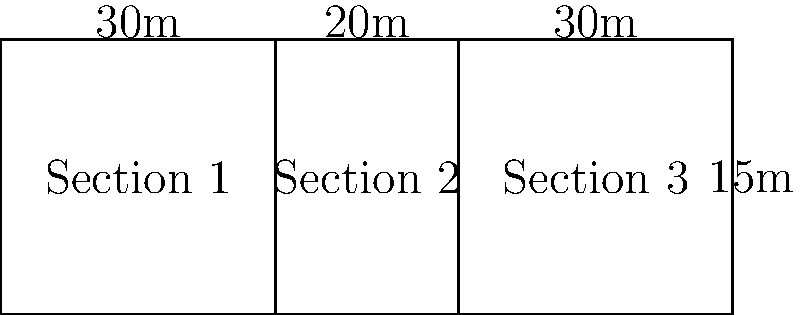As a forestry manager overseeing road maintenance, you need to resurface a section of forest road. The road is divided into three rectangular sections as shown in the diagram. The total length of the road is 80 meters, and its width is 15 meters. The first and third sections are each 30 meters long. What is the total area of road that needs to be resurfaced? To solve this problem, we'll follow these steps:

1. Calculate the length of the second section:
   Total length = Section 1 + Section 2 + Section 3
   $80 = 30 + x + 30$
   $x = 80 - 60 = 20$ meters

2. Calculate the area of each section:
   Area = length × width
   Section 1: $A_1 = 30 \times 15 = 450$ sq meters
   Section 2: $A_2 = 20 \times 15 = 300$ sq meters
   Section 3: $A_3 = 30 \times 15 = 450$ sq meters

3. Sum up the areas of all sections:
   Total Area = $A_1 + A_2 + A_3$
   $= 450 + 300 + 450$
   $= 1200$ sq meters

Therefore, the total area of road that needs to be resurfaced is 1200 square meters.
Answer: 1200 sq meters 